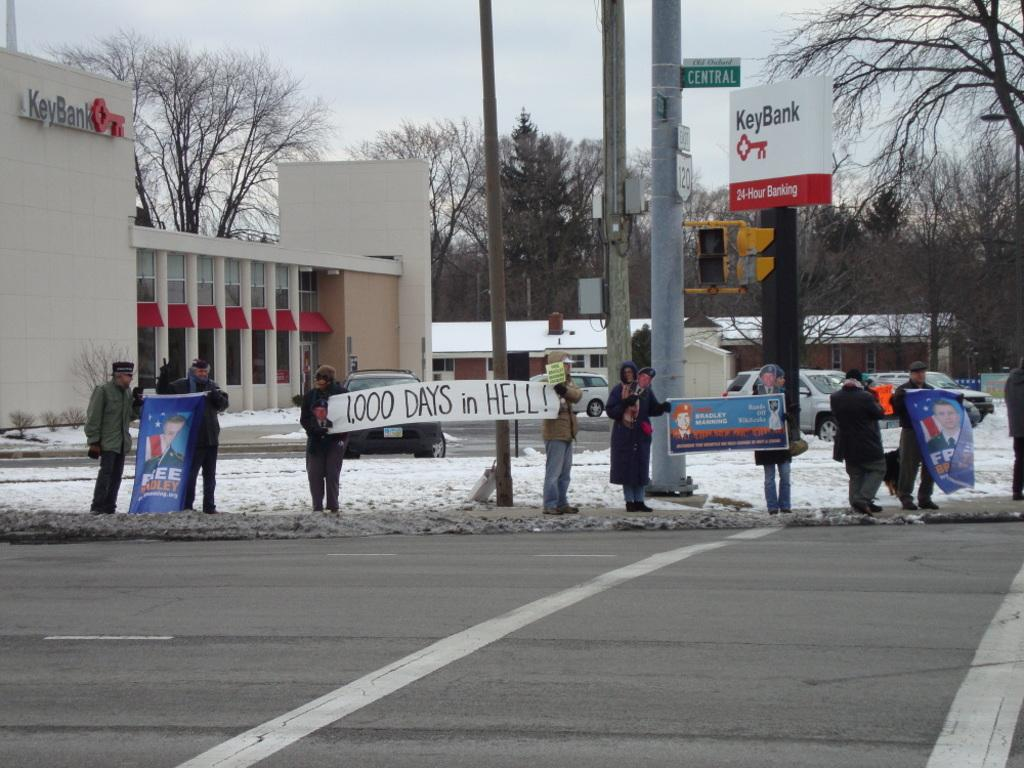What types of subjects can be seen in the image? There are people, vehicles, buildings, poles, trees, and boards with text in the image. Can you describe the environment in the image? The ground, sky, and snow are visible in the image. What might be used for transportation in the image? Vehicles can be seen in the image. What type of signage is present in the image? Boards with text are present in the image. What type of disease is affecting the man in the image? There is no man present in the image, and therefore no disease can be observed. What type of trail can be seen in the image? There is no trail present in the image. 